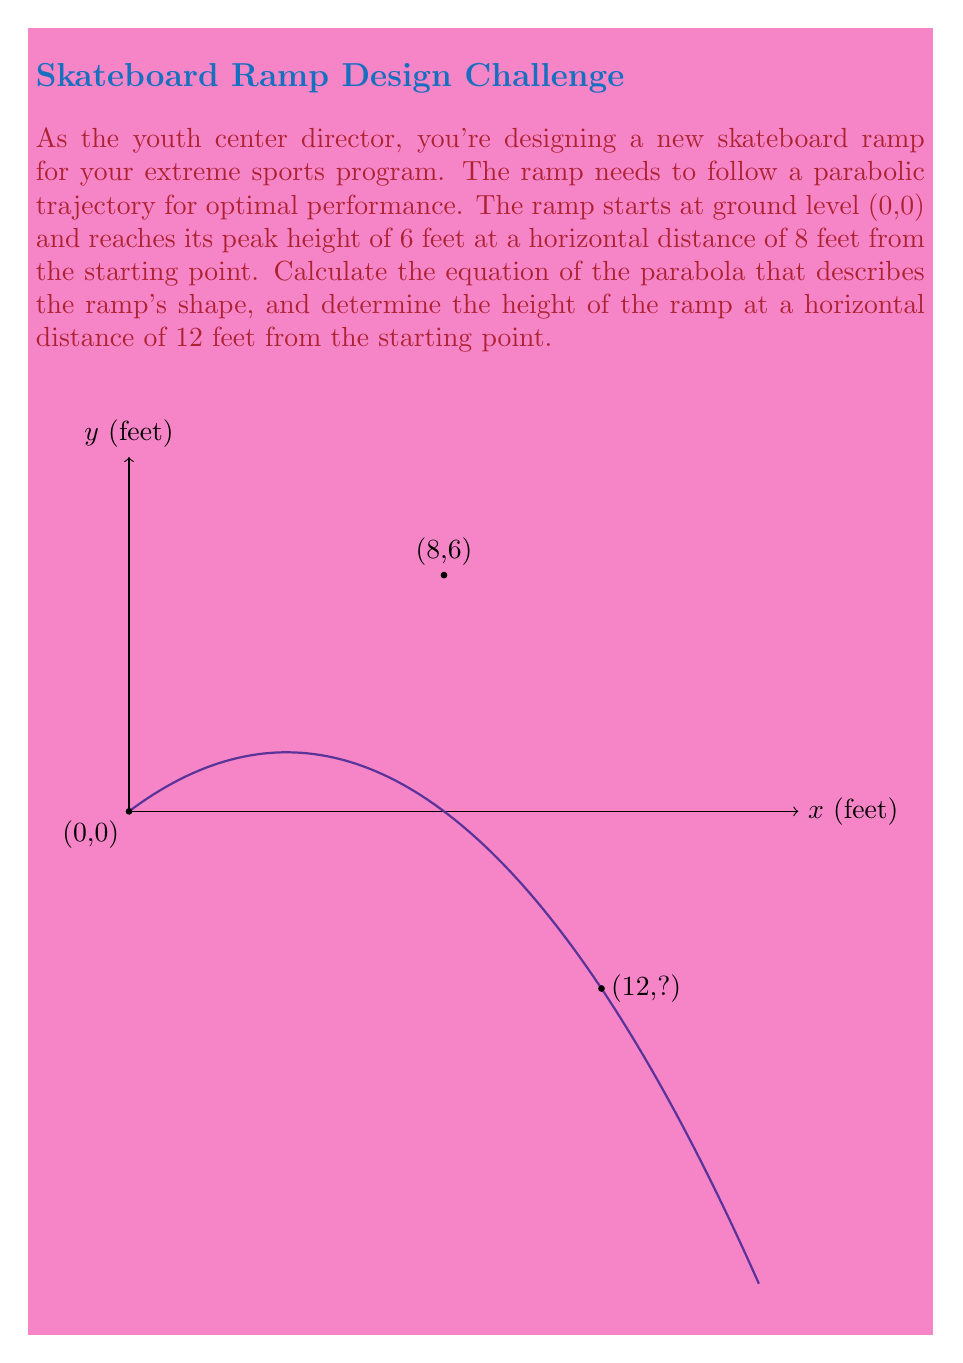Solve this math problem. Let's approach this step-by-step:

1) The general equation of a parabola with a vertical axis of symmetry is:
   $$y = a(x-h)^2 + k$$
   where (h,k) is the vertex of the parabola.

2) We know that the ramp starts at (0,0) and reaches its peak at (8,6). This means the vertex of the parabola is (8,6).

3) Substituting h=8 and k=6 into our general equation:
   $$y = a(x-8)^2 + 6$$

4) We can find 'a' by using the point (0,0):
   $$0 = a(0-8)^2 + 6$$
   $$0 = 64a + 6$$
   $$-6 = 64a$$
   $$a = -\frac{3}{32}$$

5) Therefore, the equation of the parabola is:
   $$y = -\frac{3}{32}(x-8)^2 + 6$$

6) To find the height at x=12, we substitute x=12 into our equation:
   $$y = -\frac{3}{32}(12-8)^2 + 6$$
   $$y = -\frac{3}{32}(4)^2 + 6$$
   $$y = -\frac{3}{32}(16) + 6$$
   $$y = -\frac{3}{2} + 6 = 4.5$$

Thus, at a horizontal distance of 12 feet, the ramp height is 4.5 feet.
Answer: $y = -\frac{3}{32}(x-8)^2 + 6$; Height at x=12 is 4.5 feet 